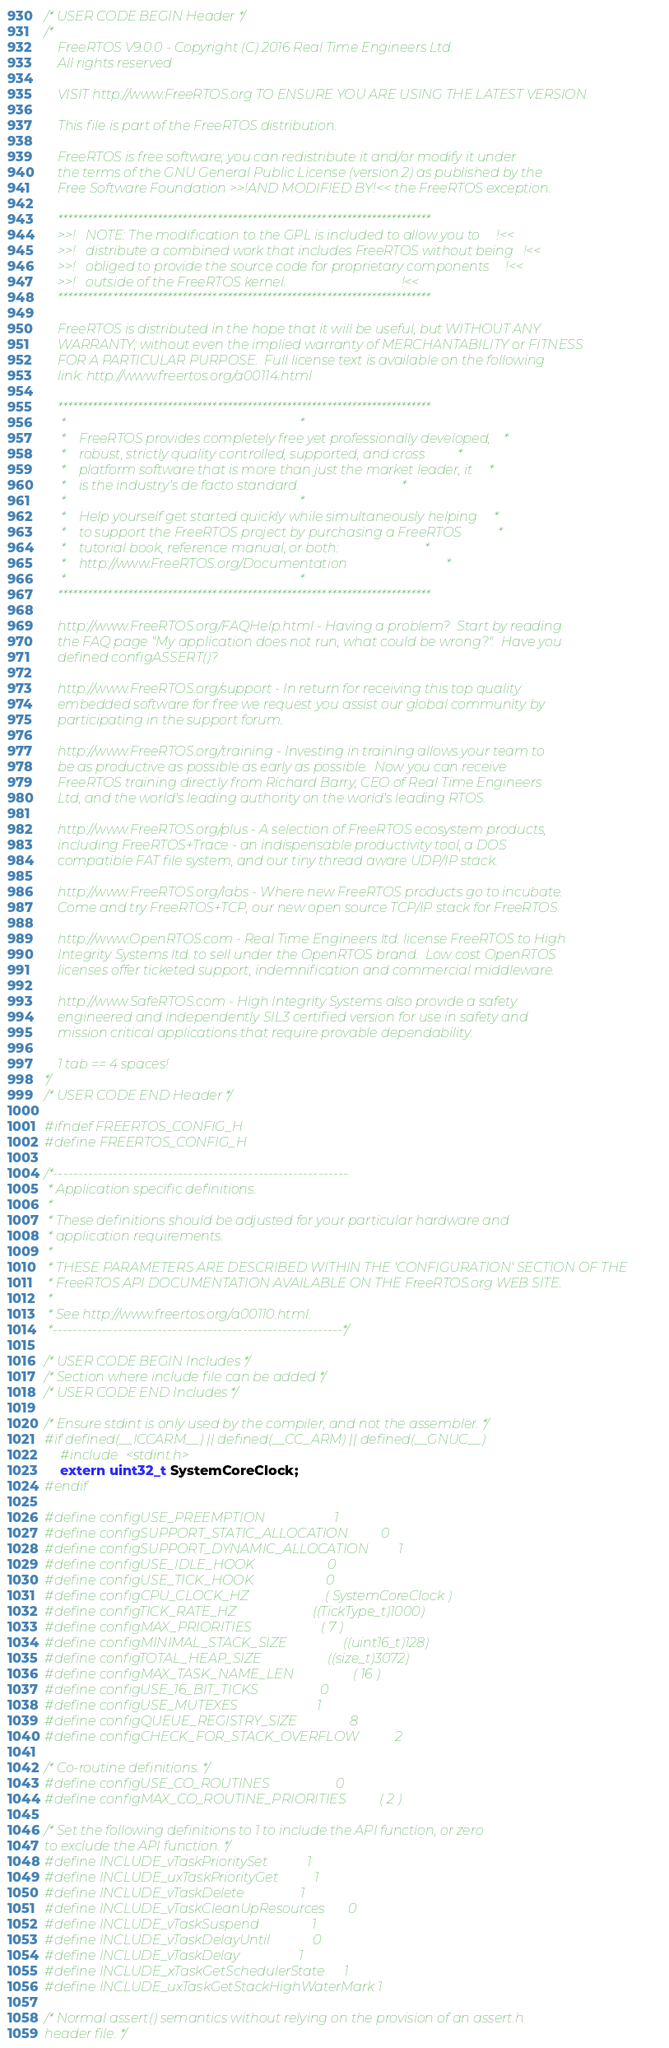<code> <loc_0><loc_0><loc_500><loc_500><_C_>/* USER CODE BEGIN Header */
/*
    FreeRTOS V9.0.0 - Copyright (C) 2016 Real Time Engineers Ltd.
    All rights reserved

    VISIT http://www.FreeRTOS.org TO ENSURE YOU ARE USING THE LATEST VERSION.

    This file is part of the FreeRTOS distribution.

    FreeRTOS is free software; you can redistribute it and/or modify it under
    the terms of the GNU General Public License (version 2) as published by the
    Free Software Foundation >>!AND MODIFIED BY!<< the FreeRTOS exception.

	***************************************************************************
    >>!   NOTE: The modification to the GPL is included to allow you to     !<<
    >>!   distribute a combined work that includes FreeRTOS without being   !<<
    >>!   obliged to provide the source code for proprietary components     !<<
    >>!   outside of the FreeRTOS kernel.                                   !<<
	***************************************************************************

    FreeRTOS is distributed in the hope that it will be useful, but WITHOUT ANY
    WARRANTY; without even the implied warranty of MERCHANTABILITY or FITNESS
    FOR A PARTICULAR PURPOSE.  Full license text is available on the following
    link: http://www.freertos.org/a00114.html

    ***************************************************************************
     *                                                                       *
     *    FreeRTOS provides completely free yet professionally developed,    *
     *    robust, strictly quality controlled, supported, and cross          *
     *    platform software that is more than just the market leader, it     *
     *    is the industry's de facto standard.                               *
     *                                                                       *
     *    Help yourself get started quickly while simultaneously helping     *
     *    to support the FreeRTOS project by purchasing a FreeRTOS           *
     *    tutorial book, reference manual, or both:                          *
     *    http://www.FreeRTOS.org/Documentation                              *
     *                                                                       *
    ***************************************************************************

    http://www.FreeRTOS.org/FAQHelp.html - Having a problem?  Start by reading
	the FAQ page "My application does not run, what could be wrong?".  Have you
	defined configASSERT()?

	http://www.FreeRTOS.org/support - In return for receiving this top quality
	embedded software for free we request you assist our global community by
	participating in the support forum.

	http://www.FreeRTOS.org/training - Investing in training allows your team to
	be as productive as possible as early as possible.  Now you can receive
	FreeRTOS training directly from Richard Barry, CEO of Real Time Engineers
	Ltd, and the world's leading authority on the world's leading RTOS.

    http://www.FreeRTOS.org/plus - A selection of FreeRTOS ecosystem products,
    including FreeRTOS+Trace - an indispensable productivity tool, a DOS
    compatible FAT file system, and our tiny thread aware UDP/IP stack.

    http://www.FreeRTOS.org/labs - Where new FreeRTOS products go to incubate.
    Come and try FreeRTOS+TCP, our new open source TCP/IP stack for FreeRTOS.

    http://www.OpenRTOS.com - Real Time Engineers ltd. license FreeRTOS to High
    Integrity Systems ltd. to sell under the OpenRTOS brand.  Low cost OpenRTOS
    licenses offer ticketed support, indemnification and commercial middleware.

    http://www.SafeRTOS.com - High Integrity Systems also provide a safety
    engineered and independently SIL3 certified version for use in safety and
    mission critical applications that require provable dependability.

    1 tab == 4 spaces!
*/
/* USER CODE END Header */

#ifndef FREERTOS_CONFIG_H
#define FREERTOS_CONFIG_H

/*-----------------------------------------------------------
 * Application specific definitions.
 *
 * These definitions should be adjusted for your particular hardware and
 * application requirements.
 *
 * THESE PARAMETERS ARE DESCRIBED WITHIN THE 'CONFIGURATION' SECTION OF THE
 * FreeRTOS API DOCUMENTATION AVAILABLE ON THE FreeRTOS.org WEB SITE.
 *
 * See http://www.freertos.org/a00110.html.
 *----------------------------------------------------------*/

/* USER CODE BEGIN Includes */   	      
/* Section where include file can be added */
/* USER CODE END Includes */ 

/* Ensure stdint is only used by the compiler, and not the assembler. */
#if defined(__ICCARM__) || defined(__CC_ARM) || defined(__GNUC__)
    #include <stdint.h>
    extern uint32_t SystemCoreClock;
#endif

#define configUSE_PREEMPTION                     1
#define configSUPPORT_STATIC_ALLOCATION          0
#define configSUPPORT_DYNAMIC_ALLOCATION         1
#define configUSE_IDLE_HOOK                      0
#define configUSE_TICK_HOOK                      0
#define configCPU_CLOCK_HZ                       ( SystemCoreClock )
#define configTICK_RATE_HZ                       ((TickType_t)1000)
#define configMAX_PRIORITIES                     ( 7 )
#define configMINIMAL_STACK_SIZE                 ((uint16_t)128)
#define configTOTAL_HEAP_SIZE                    ((size_t)3072)
#define configMAX_TASK_NAME_LEN                  ( 16 )
#define configUSE_16_BIT_TICKS                   0
#define configUSE_MUTEXES                        1
#define configQUEUE_REGISTRY_SIZE                8
#define configCHECK_FOR_STACK_OVERFLOW           2

/* Co-routine definitions. */
#define configUSE_CO_ROUTINES                    0
#define configMAX_CO_ROUTINE_PRIORITIES          ( 2 )

/* Set the following definitions to 1 to include the API function, or zero
to exclude the API function. */
#define INCLUDE_vTaskPrioritySet            1
#define INCLUDE_uxTaskPriorityGet           1
#define INCLUDE_vTaskDelete                 1
#define INCLUDE_vTaskCleanUpResources       0
#define INCLUDE_vTaskSuspend                1
#define INCLUDE_vTaskDelayUntil             0
#define INCLUDE_vTaskDelay                  1
#define INCLUDE_xTaskGetSchedulerState      1
#define INCLUDE_uxTaskGetStackHighWaterMark 1

/* Normal assert() semantics without relying on the provision of an assert.h
header file. */</code> 